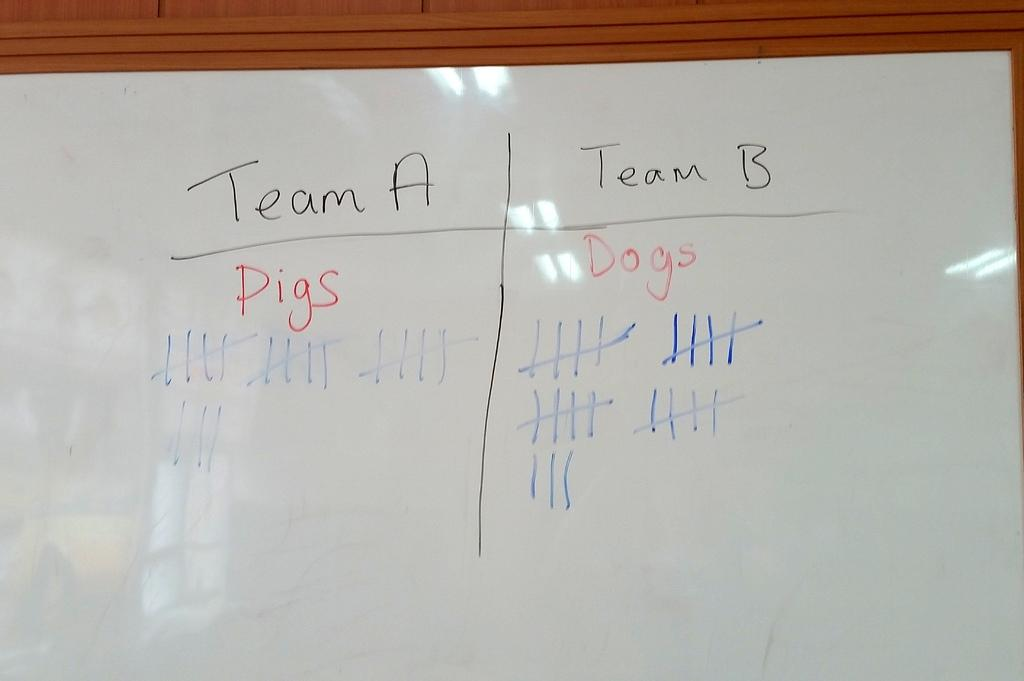<image>
Render a clear and concise summary of the photo. "Team A" and "Team B" are written on a white board. 